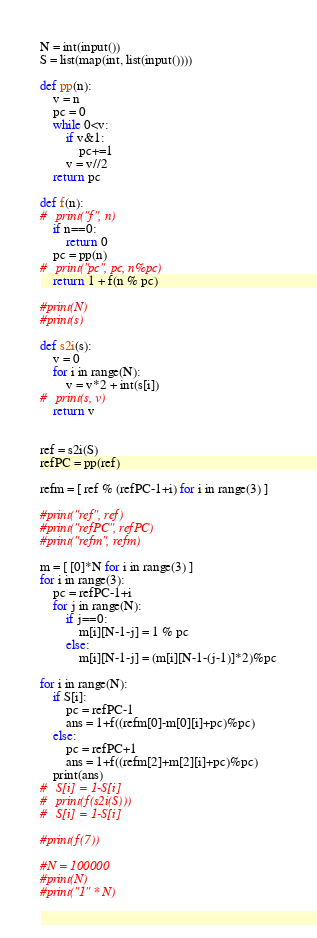<code> <loc_0><loc_0><loc_500><loc_500><_Python_>N = int(input())
S = list(map(int, list(input())))

def pp(n):
	v = n
	pc = 0
	while 0<v:
		if v&1:
			pc+=1
		v = v//2
	return pc

def f(n):
#	print("f", n)
	if n==0:
		return 0
	pc = pp(n)
#	print("pc", pc, n%pc)
	return 1 + f(n % pc)

#print(N)
#print(s)

def s2i(s):
	v = 0
	for i in range(N):
		v = v*2 + int(s[i])
#	print(s, v)
	return v


ref = s2i(S)
refPC = pp(ref)

refm = [ ref % (refPC-1+i) for i in range(3) ]

#print("ref", ref)
#print("refPC", refPC)
#print("refm", refm)

m = [ [0]*N for i in range(3) ]
for i in range(3):
	pc = refPC-1+i
	for j in range(N):
		if j==0:
			m[i][N-1-j] = 1 % pc
		else:
			m[i][N-1-j] = (m[i][N-1-(j-1)]*2)%pc

for i in range(N):
	if S[i]:
		pc = refPC-1
		ans = 1+f((refm[0]-m[0][i]+pc)%pc)
	else:
		pc = refPC+1
		ans = 1+f((refm[2]+m[2][i]+pc)%pc)
	print(ans)
#	S[i] = 1-S[i]
#	print(f(s2i(S)))
#	S[i] = 1-S[i]

#print(f(7))

#N = 100000
#print(N)
#print("1" * N)
</code> 